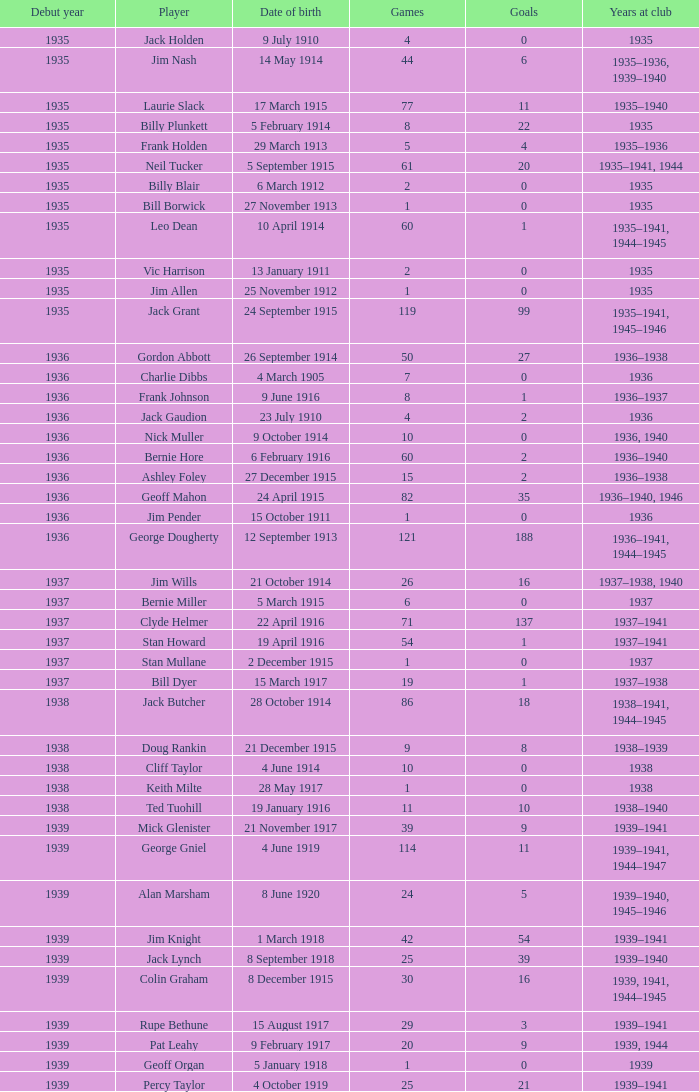What is the lowest number of games Jack Gaudion, who debut in 1936, played? 4.0. 